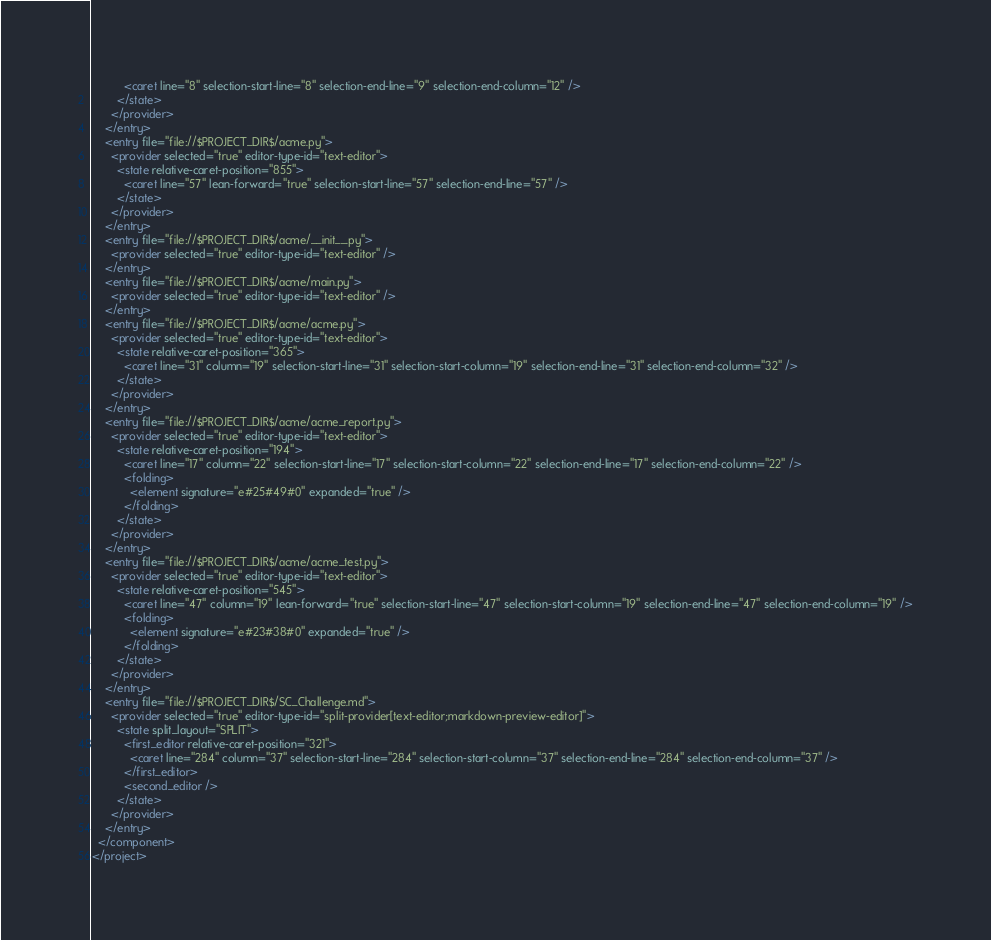Convert code to text. <code><loc_0><loc_0><loc_500><loc_500><_XML_>          <caret line="8" selection-start-line="8" selection-end-line="9" selection-end-column="12" />
        </state>
      </provider>
    </entry>
    <entry file="file://$PROJECT_DIR$/acme.py">
      <provider selected="true" editor-type-id="text-editor">
        <state relative-caret-position="855">
          <caret line="57" lean-forward="true" selection-start-line="57" selection-end-line="57" />
        </state>
      </provider>
    </entry>
    <entry file="file://$PROJECT_DIR$/acme/__init__.py">
      <provider selected="true" editor-type-id="text-editor" />
    </entry>
    <entry file="file://$PROJECT_DIR$/acme/main.py">
      <provider selected="true" editor-type-id="text-editor" />
    </entry>
    <entry file="file://$PROJECT_DIR$/acme/acme.py">
      <provider selected="true" editor-type-id="text-editor">
        <state relative-caret-position="365">
          <caret line="31" column="19" selection-start-line="31" selection-start-column="19" selection-end-line="31" selection-end-column="32" />
        </state>
      </provider>
    </entry>
    <entry file="file://$PROJECT_DIR$/acme/acme_report.py">
      <provider selected="true" editor-type-id="text-editor">
        <state relative-caret-position="194">
          <caret line="17" column="22" selection-start-line="17" selection-start-column="22" selection-end-line="17" selection-end-column="22" />
          <folding>
            <element signature="e#25#49#0" expanded="true" />
          </folding>
        </state>
      </provider>
    </entry>
    <entry file="file://$PROJECT_DIR$/acme/acme_test.py">
      <provider selected="true" editor-type-id="text-editor">
        <state relative-caret-position="545">
          <caret line="47" column="19" lean-forward="true" selection-start-line="47" selection-start-column="19" selection-end-line="47" selection-end-column="19" />
          <folding>
            <element signature="e#23#38#0" expanded="true" />
          </folding>
        </state>
      </provider>
    </entry>
    <entry file="file://$PROJECT_DIR$/SC_Challenge.md">
      <provider selected="true" editor-type-id="split-provider[text-editor;markdown-preview-editor]">
        <state split_layout="SPLIT">
          <first_editor relative-caret-position="321">
            <caret line="284" column="37" selection-start-line="284" selection-start-column="37" selection-end-line="284" selection-end-column="37" />
          </first_editor>
          <second_editor />
        </state>
      </provider>
    </entry>
  </component>
</project></code> 